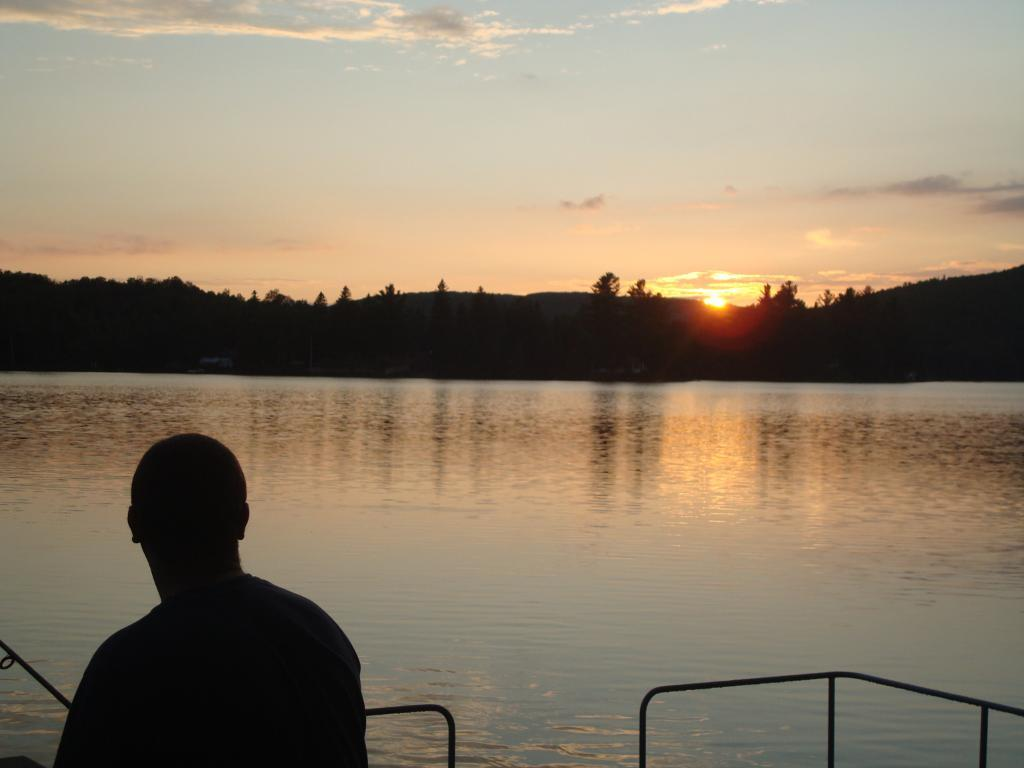Who or what is present in the image? There is a person in the image. What objects are in front of the person? There are rods in front of the person. What natural element is visible in the image? There is water visible in the image. What type of vegetation can be seen in the background of the image? There are trees in the background of the image. What celestial body and atmospheric element are visible in the background of the image? The sun and the sky are visible in the background of the image. What type of school is depicted in the image? There is no school present in the image. 